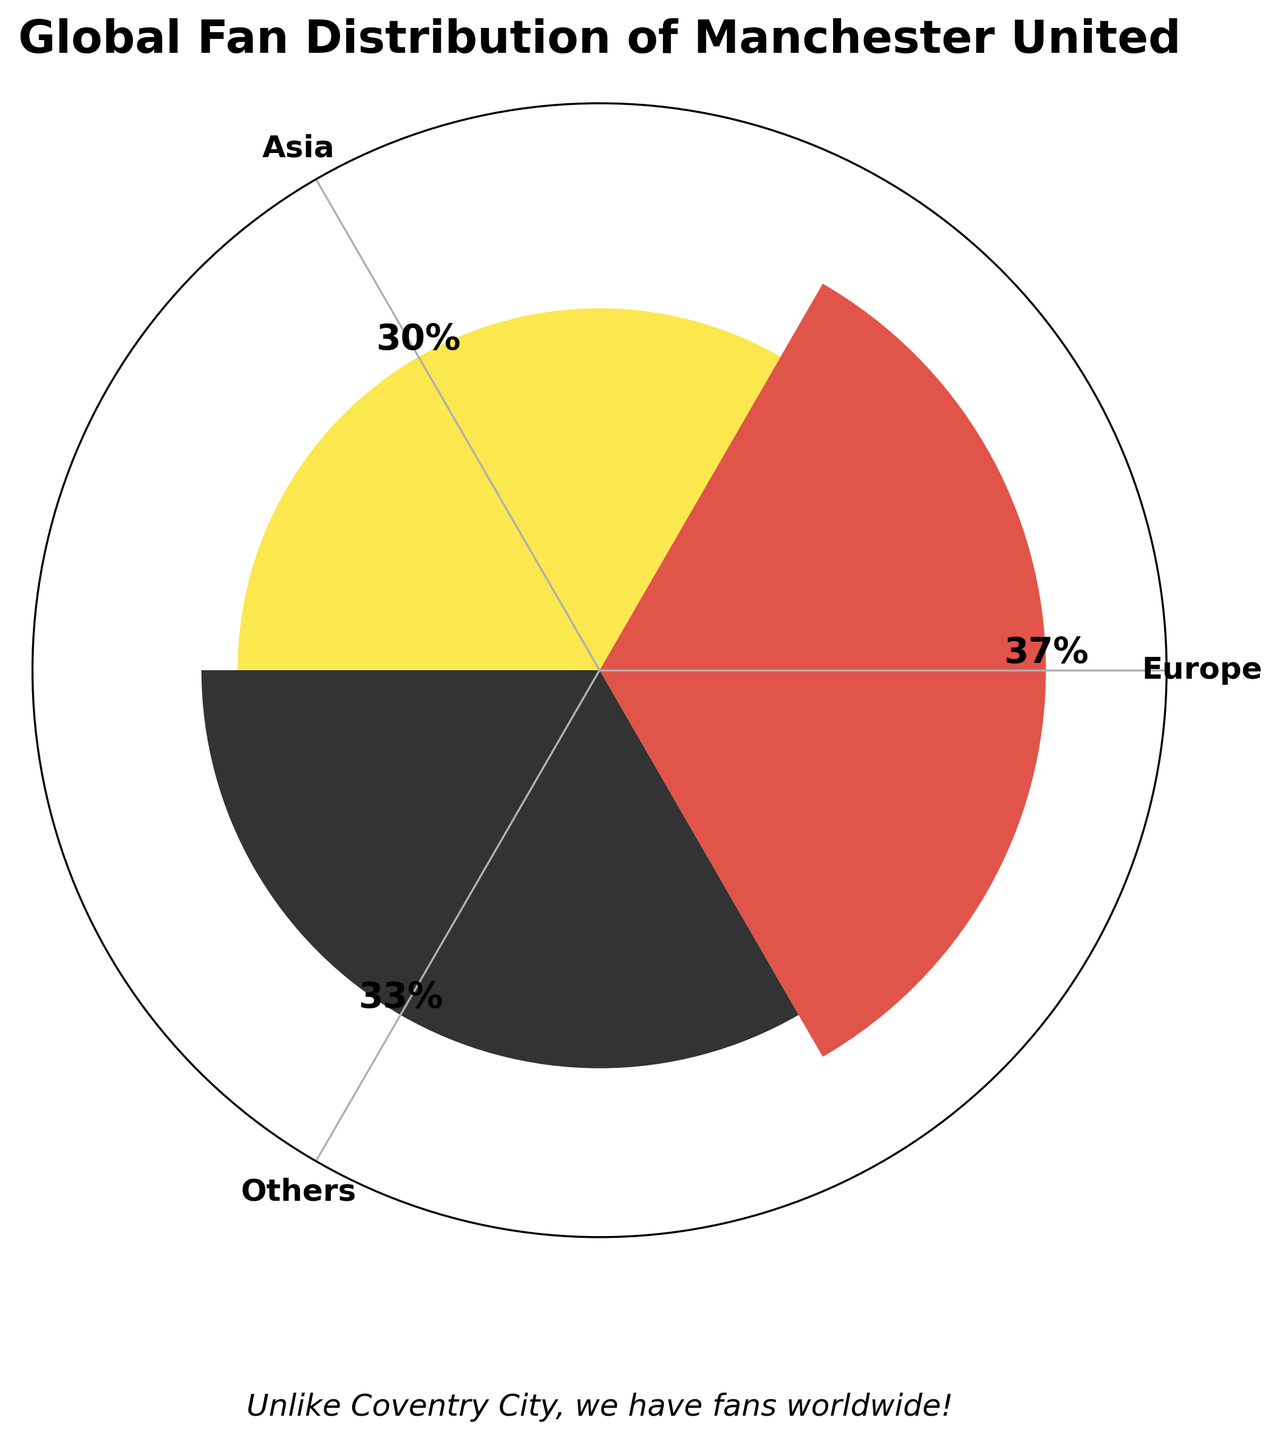Which continent has the highest percentage of Manchester United fans? The continents listed are Europe, Asia, and Others. Europe has the highest percentage at 37%.
Answer: Europe What is the combined percentage of Manchester United fans in Europe and Asia? Adding the percentage of fans in Europe (37%) to the percentage of fans in Asia (30%) gives a combined value of 67%.
Answer: 67% How does the percentage of fans in 'Others' compare to that in Asia? The percentage of fans in 'Others' is 33%, while in Asia it is 30%. 33% is slightly higher than 30%.
Answer: 'Others' has a higher percentage What percentage of fans are in continents other than Europe? The percentages in Asia and 'Others' are 30% and 33%, respectively. Adding these gives 63%.
Answer: 63% Which two continents have similar percentages of Manchester United fans? The percentages are close between Asia (30%) and 'Others' (33%), with only a 3% difference.
Answer: Asia and 'Others' What is the difference in percentage between the continent with the highest and the continent with the lowest number of Manchester United fans? Europe has the highest percentage (37%) and Asia has the lowest (30%). The difference is 37% - 30% = 7%.
Answer: 7% How does the visualization distinguish between different continents? The visualization uses different colors: red for Europe, yellow for Asia, and black for 'Others'.
Answer: Different colors What is the title of the rose chart? The title of the rose chart is "Global Fan Distribution of Manchester United".
Answer: Global Fan Distribution of Manchester United Is the distribution of Manchester United fans evenly spread across the continents represented? The percentages vary: 37% in Europe, 30% in Asia, and 33% in 'Others', indicating an uneven distribution.
Answer: No How is the percentage data represented visually in the rose chart? The percentages are represented by the height of bars in a polar plot, with each bar corresponding to a continent.
Answer: Height of bars in a polar plot 